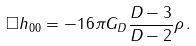<formula> <loc_0><loc_0><loc_500><loc_500>\square h _ { 0 0 } = - 1 6 \pi G _ { D } \frac { D - 3 } { D - 2 } \rho \, .</formula> 